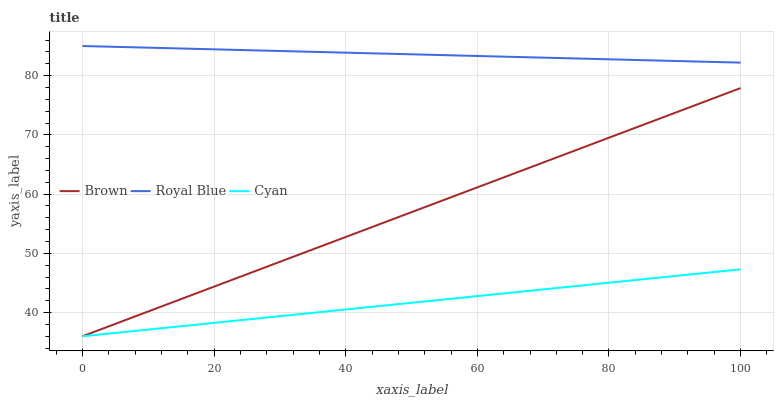Does Cyan have the minimum area under the curve?
Answer yes or no. Yes. Does Royal Blue have the maximum area under the curve?
Answer yes or no. Yes. Does Royal Blue have the minimum area under the curve?
Answer yes or no. No. Does Cyan have the maximum area under the curve?
Answer yes or no. No. Is Cyan the smoothest?
Answer yes or no. Yes. Is Royal Blue the roughest?
Answer yes or no. Yes. Is Royal Blue the smoothest?
Answer yes or no. No. Is Cyan the roughest?
Answer yes or no. No. Does Brown have the lowest value?
Answer yes or no. Yes. Does Royal Blue have the lowest value?
Answer yes or no. No. Does Royal Blue have the highest value?
Answer yes or no. Yes. Does Cyan have the highest value?
Answer yes or no. No. Is Cyan less than Royal Blue?
Answer yes or no. Yes. Is Royal Blue greater than Cyan?
Answer yes or no. Yes. Does Cyan intersect Brown?
Answer yes or no. Yes. Is Cyan less than Brown?
Answer yes or no. No. Is Cyan greater than Brown?
Answer yes or no. No. Does Cyan intersect Royal Blue?
Answer yes or no. No. 